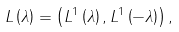<formula> <loc_0><loc_0><loc_500><loc_500>L \left ( \lambda \right ) = \left ( L ^ { 1 } \left ( \lambda \right ) , L ^ { 1 } \left ( - \lambda \right ) \right ) ,</formula> 